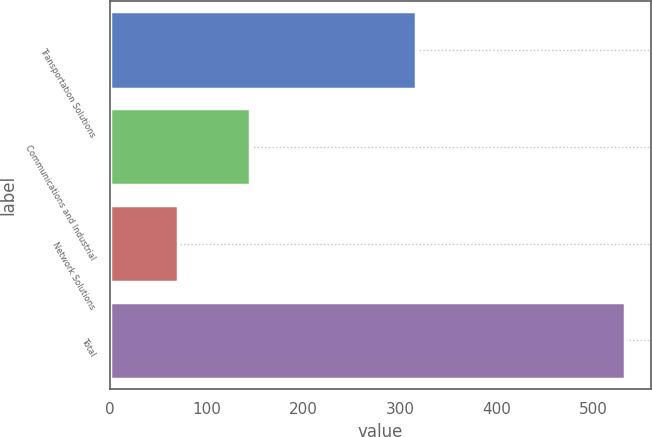Convert chart. <chart><loc_0><loc_0><loc_500><loc_500><bar_chart><fcel>Transportation Solutions<fcel>Communications and Industrial<fcel>Network Solutions<fcel>Total<nl><fcel>317<fcel>145<fcel>71<fcel>533<nl></chart> 